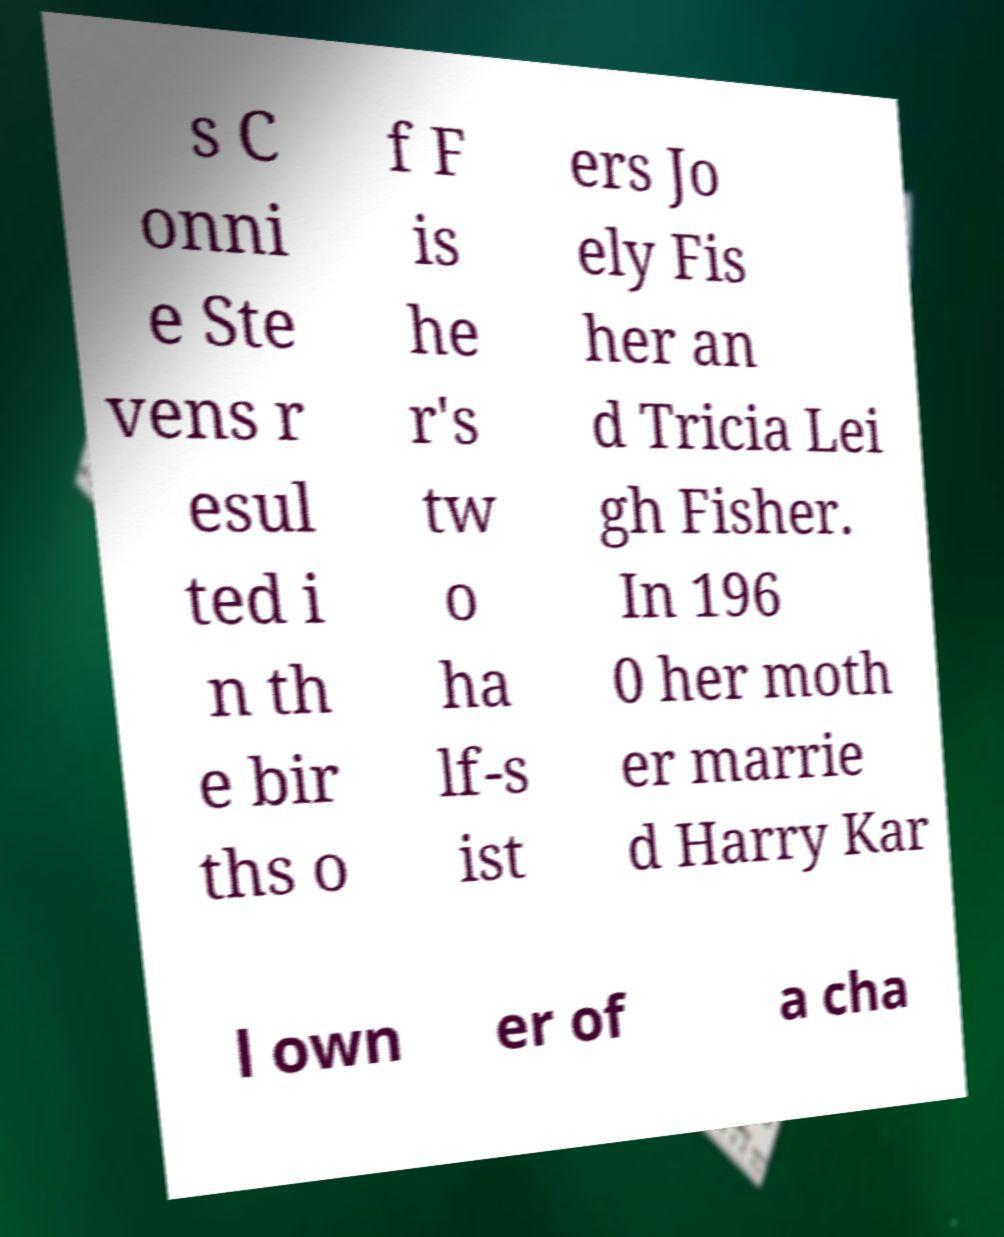Could you assist in decoding the text presented in this image and type it out clearly? s C onni e Ste vens r esul ted i n th e bir ths o f F is he r's tw o ha lf-s ist ers Jo ely Fis her an d Tricia Lei gh Fisher. In 196 0 her moth er marrie d Harry Kar l own er of a cha 